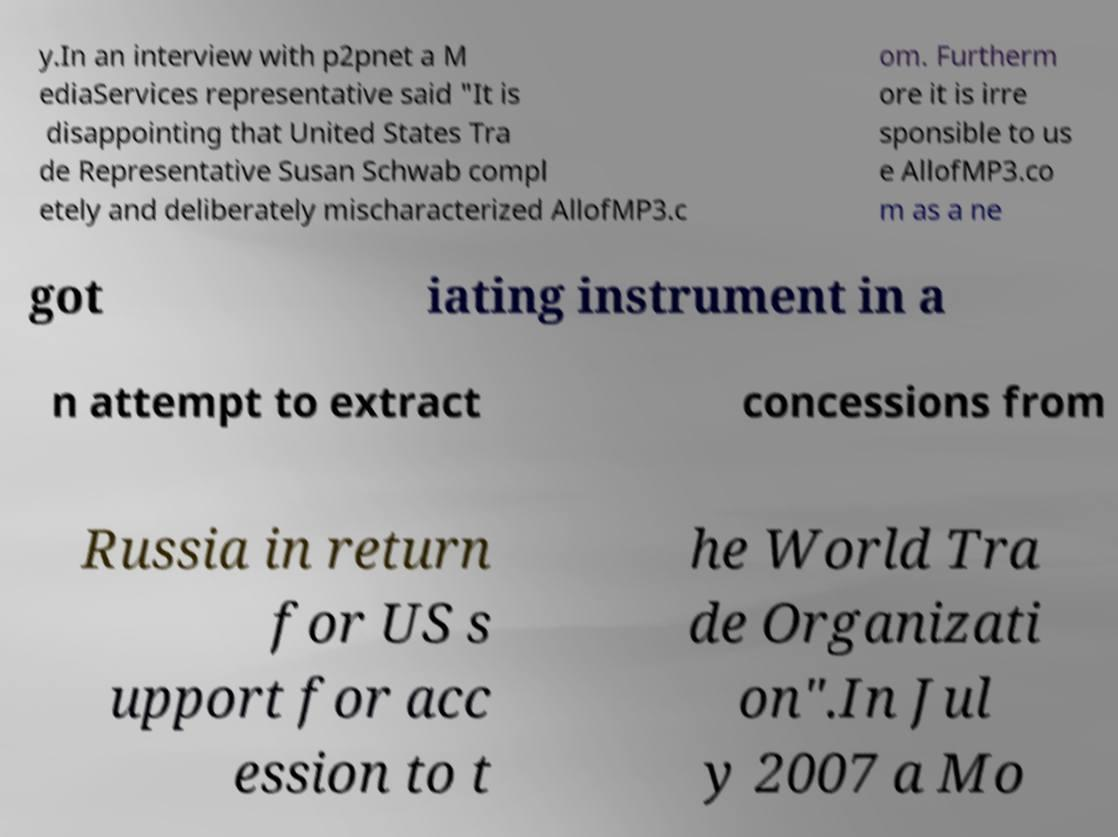Could you extract and type out the text from this image? y.In an interview with p2pnet a M ediaServices representative said "It is disappointing that United States Tra de Representative Susan Schwab compl etely and deliberately mischaracterized AllofMP3.c om. Furtherm ore it is irre sponsible to us e AllofMP3.co m as a ne got iating instrument in a n attempt to extract concessions from Russia in return for US s upport for acc ession to t he World Tra de Organizati on".In Jul y 2007 a Mo 